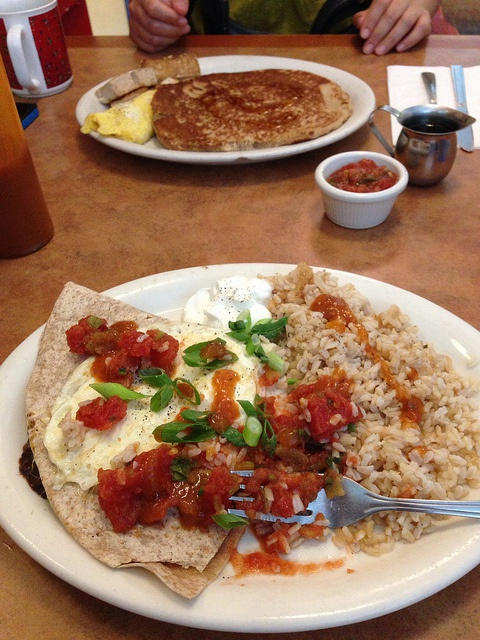Describe the objects in this image and their specific colors. I can see dining table in lightgray, brown, salmon, maroon, and black tones, people in lightgray, black, brown, and maroon tones, fork in lightgray, gray, maroon, darkgray, and brown tones, cup in lightgray, maroon, and darkgray tones, and bottle in lightgray, maroon, and brown tones in this image. 